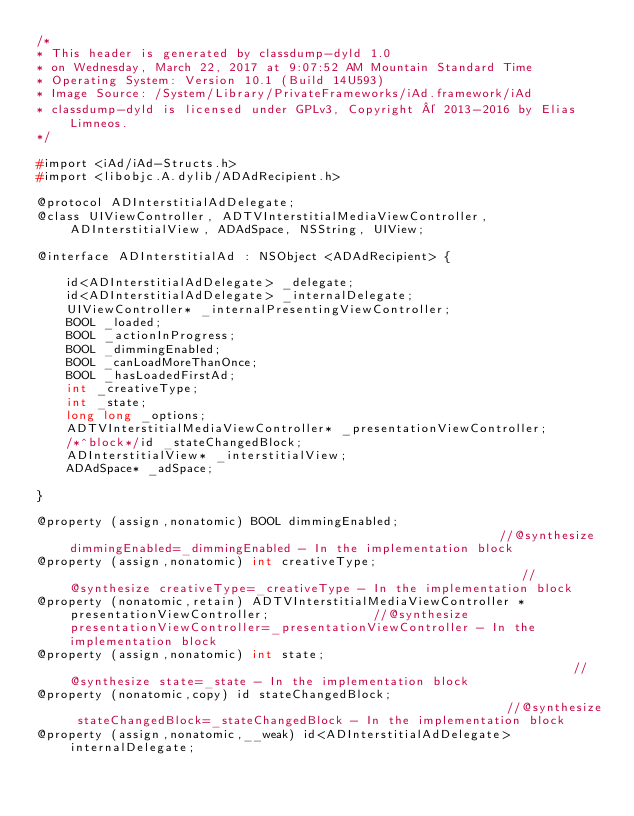Convert code to text. <code><loc_0><loc_0><loc_500><loc_500><_C_>/*
* This header is generated by classdump-dyld 1.0
* on Wednesday, March 22, 2017 at 9:07:52 AM Mountain Standard Time
* Operating System: Version 10.1 (Build 14U593)
* Image Source: /System/Library/PrivateFrameworks/iAd.framework/iAd
* classdump-dyld is licensed under GPLv3, Copyright © 2013-2016 by Elias Limneos.
*/

#import <iAd/iAd-Structs.h>
#import <libobjc.A.dylib/ADAdRecipient.h>

@protocol ADInterstitialAdDelegate;
@class UIViewController, ADTVInterstitialMediaViewController, ADInterstitialView, ADAdSpace, NSString, UIView;

@interface ADInterstitialAd : NSObject <ADAdRecipient> {

	id<ADInterstitialAdDelegate> _delegate;
	id<ADInterstitialAdDelegate> _internalDelegate;
	UIViewController* _internalPresentingViewController;
	BOOL _loaded;
	BOOL _actionInProgress;
	BOOL _dimmingEnabled;
	BOOL _canLoadMoreThanOnce;
	BOOL _hasLoadedFirstAd;
	int _creativeType;
	int _state;
	long long _options;
	ADTVInterstitialMediaViewController* _presentationViewController;
	/*^block*/id _stateChangedBlock;
	ADInterstitialView* _interstitialView;
	ADAdSpace* _adSpace;

}

@property (assign,nonatomic) BOOL dimmingEnabled;                                                           //@synthesize dimmingEnabled=_dimmingEnabled - In the implementation block
@property (assign,nonatomic) int creativeType;                                                              //@synthesize creativeType=_creativeType - In the implementation block
@property (nonatomic,retain) ADTVInterstitialMediaViewController * presentationViewController;              //@synthesize presentationViewController=_presentationViewController - In the implementation block
@property (assign,nonatomic) int state;                                                                     //@synthesize state=_state - In the implementation block
@property (nonatomic,copy) id stateChangedBlock;                                                            //@synthesize stateChangedBlock=_stateChangedBlock - In the implementation block
@property (assign,nonatomic,__weak) id<ADInterstitialAdDelegate> internalDelegate; </code> 